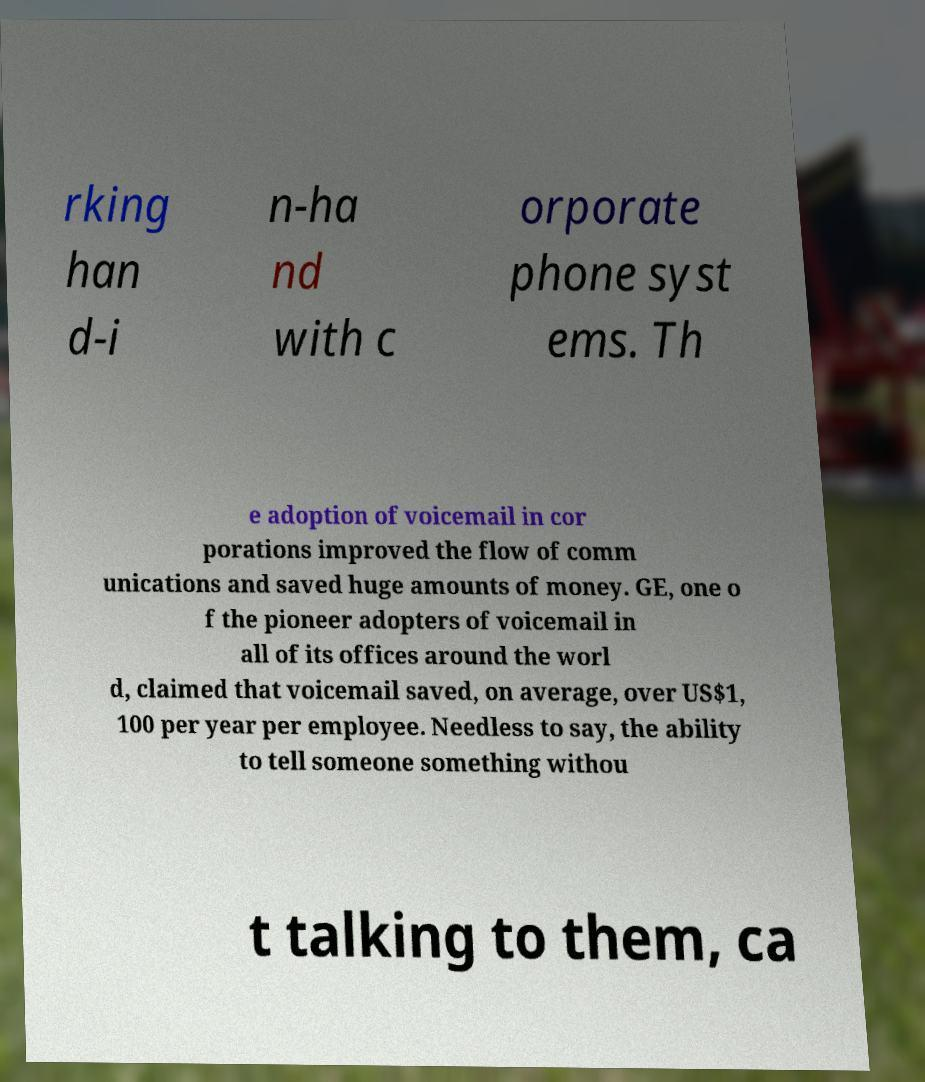Could you extract and type out the text from this image? rking han d-i n-ha nd with c orporate phone syst ems. Th e adoption of voicemail in cor porations improved the flow of comm unications and saved huge amounts of money. GE, one o f the pioneer adopters of voicemail in all of its offices around the worl d, claimed that voicemail saved, on average, over US$1, 100 per year per employee. Needless to say, the ability to tell someone something withou t talking to them, ca 